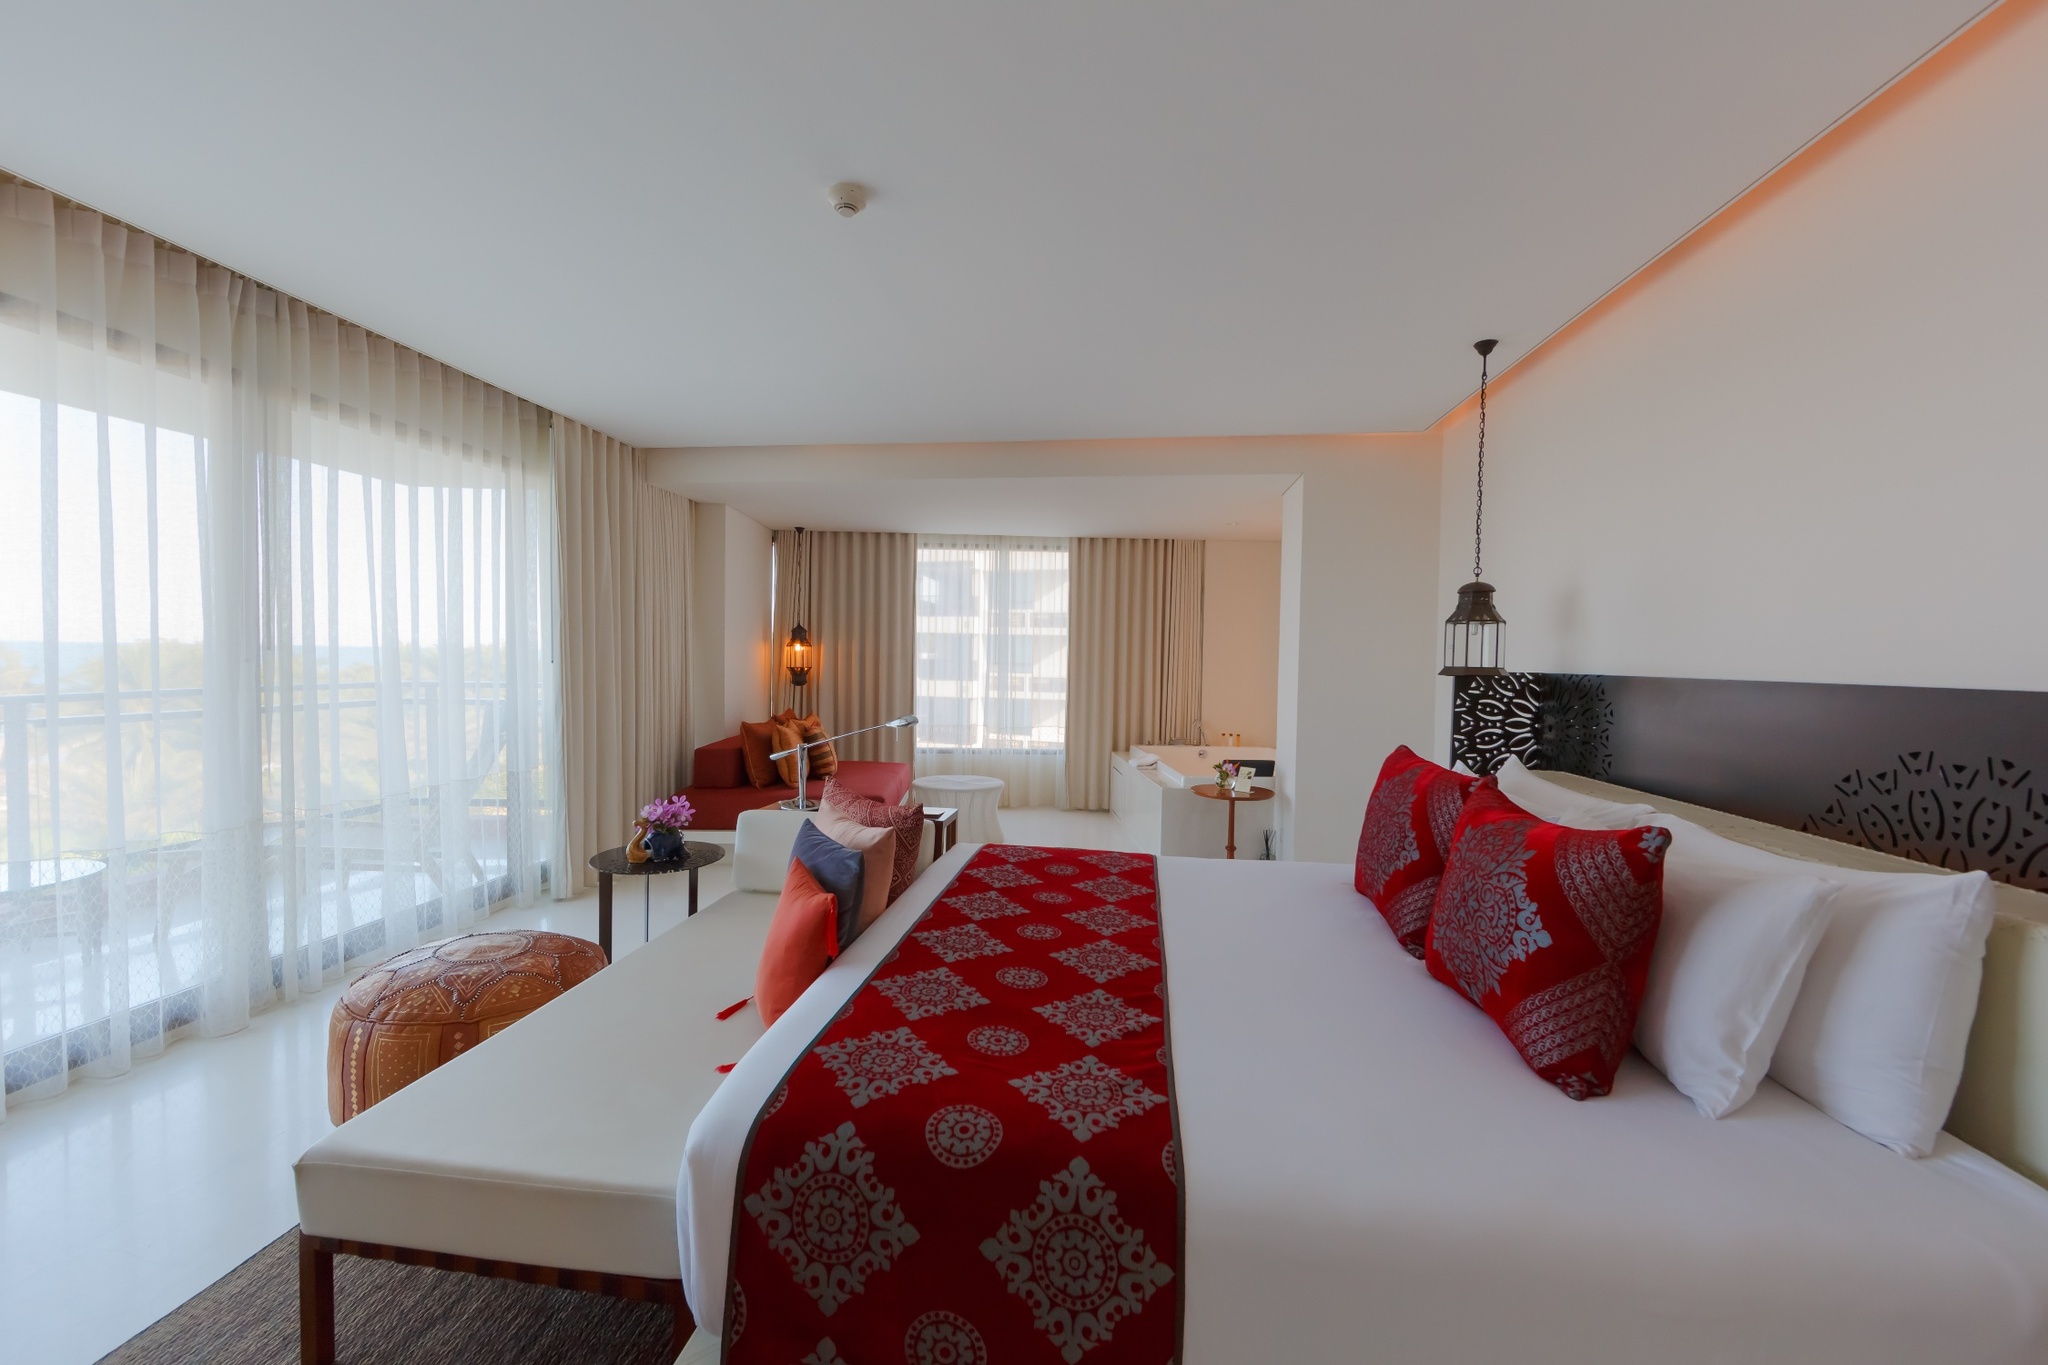If this hotel room could talk, what stories would it share about its guests? If this hotel room could talk, it would share tales of whispered conversations under the blanket of night, laughter echoing during family reunions, and the quiet musings of solo travelers finding a slice of peace away from their chaotic lives. The walls have heard the dreams of honeymooning couples, the plans of business travelers strategizing for success, and the reflections of wanderers exploring new horizons. Each pillow has cradled the heads of countless guests, offering comfort and solace, while the gentle rustle of the curtains has serenaded them into restful sleep. The room would tell stories of joy, reflection, connection, and discovery, all woven into the fabric of its existence. Imagine a magical event happening in this room where the objects come to life. Describe the scene. As twilight descends and the sky outside turns a majestic hue of purple and gold, a magical transformation stirs within the room. The red pillows begin to shimmy and fluff themselves, arranging into perfect plumpness. The vase of flowers on the side table gently sways, petals glowing with an ethereal light, as if whispering secrets to each other. The desk lamp flickers to life, casting a warm, inviting glow that dances across the walls, and the chair stretches its legs, shaking off the stiffness of the day. The curtains flutter as if in conversation with the evening breeze, telling tales of the sunsets they’ve seen. Finally, the bed itself gives a contented sigh, its covers rippling gently as if settling into a cozy bedtime story. This room springs to life in a harmonious dance of comfort, whispering an invitation to its next guest to enter this enchanted sanctuary. 